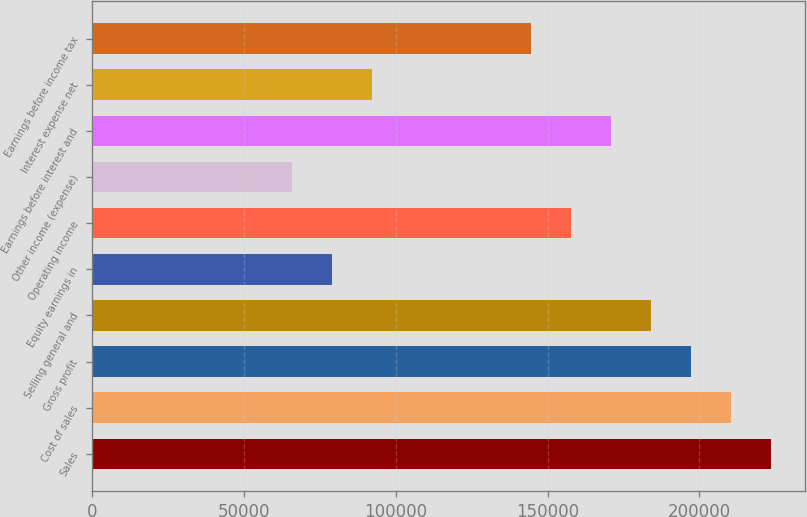<chart> <loc_0><loc_0><loc_500><loc_500><bar_chart><fcel>Sales<fcel>Cost of sales<fcel>Gross profit<fcel>Selling general and<fcel>Equity earnings in<fcel>Operating income<fcel>Other income (expense)<fcel>Earnings before interest and<fcel>Interest expense net<fcel>Earnings before income tax<nl><fcel>223612<fcel>210458<fcel>197305<fcel>184151<fcel>78922.9<fcel>157844<fcel>65769.3<fcel>170998<fcel>92076.4<fcel>144691<nl></chart> 